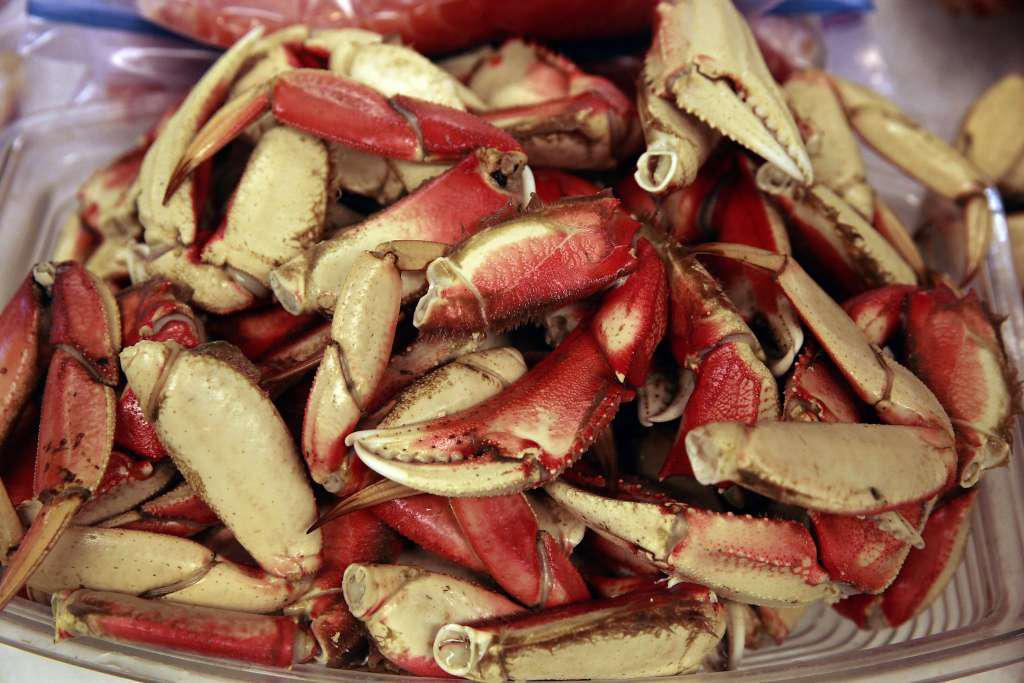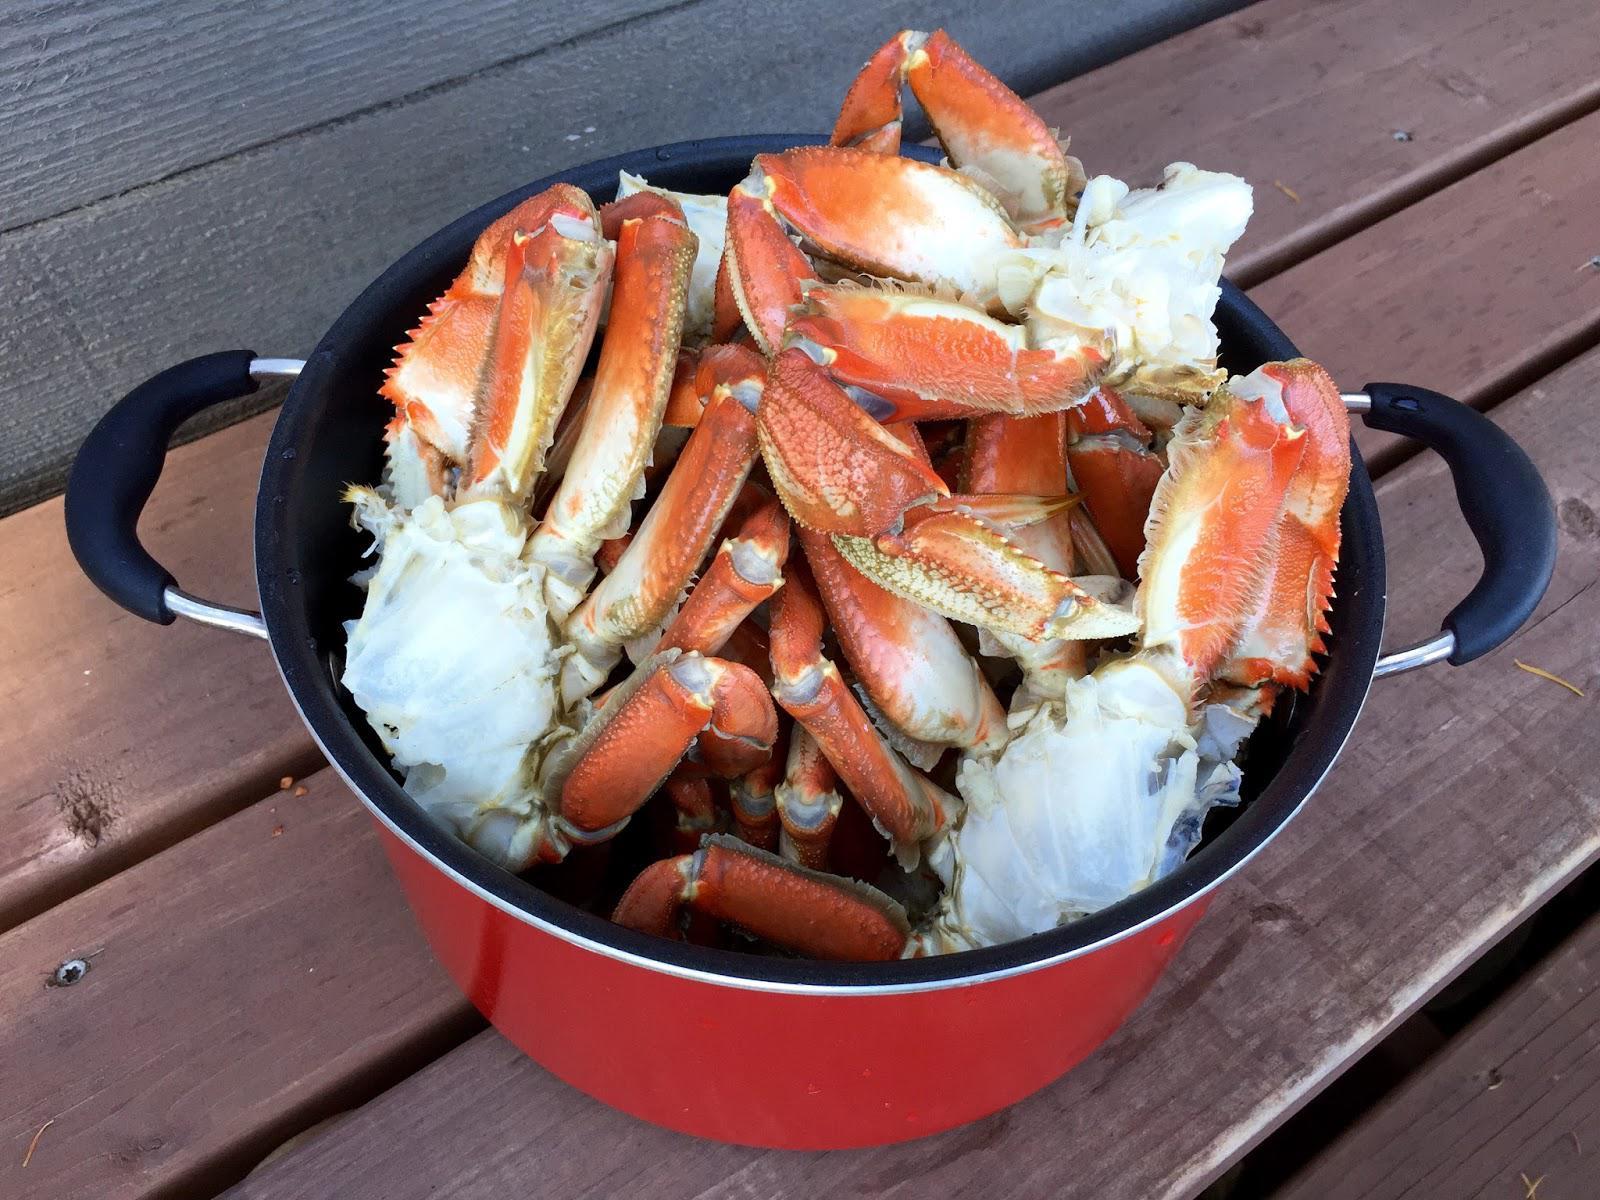The first image is the image on the left, the second image is the image on the right. Assess this claim about the two images: "One of the images has cooked crab pieces on foil.". Correct or not? Answer yes or no. No. The first image is the image on the left, the second image is the image on the right. Analyze the images presented: Is the assertion "Left and right images each show crab claws in some type of container used in a kitchen." valid? Answer yes or no. Yes. 